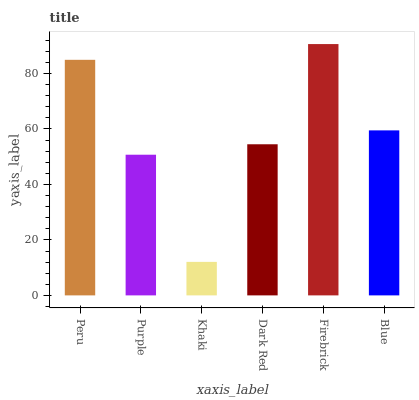Is Khaki the minimum?
Answer yes or no. Yes. Is Firebrick the maximum?
Answer yes or no. Yes. Is Purple the minimum?
Answer yes or no. No. Is Purple the maximum?
Answer yes or no. No. Is Peru greater than Purple?
Answer yes or no. Yes. Is Purple less than Peru?
Answer yes or no. Yes. Is Purple greater than Peru?
Answer yes or no. No. Is Peru less than Purple?
Answer yes or no. No. Is Blue the high median?
Answer yes or no. Yes. Is Dark Red the low median?
Answer yes or no. Yes. Is Khaki the high median?
Answer yes or no. No. Is Khaki the low median?
Answer yes or no. No. 